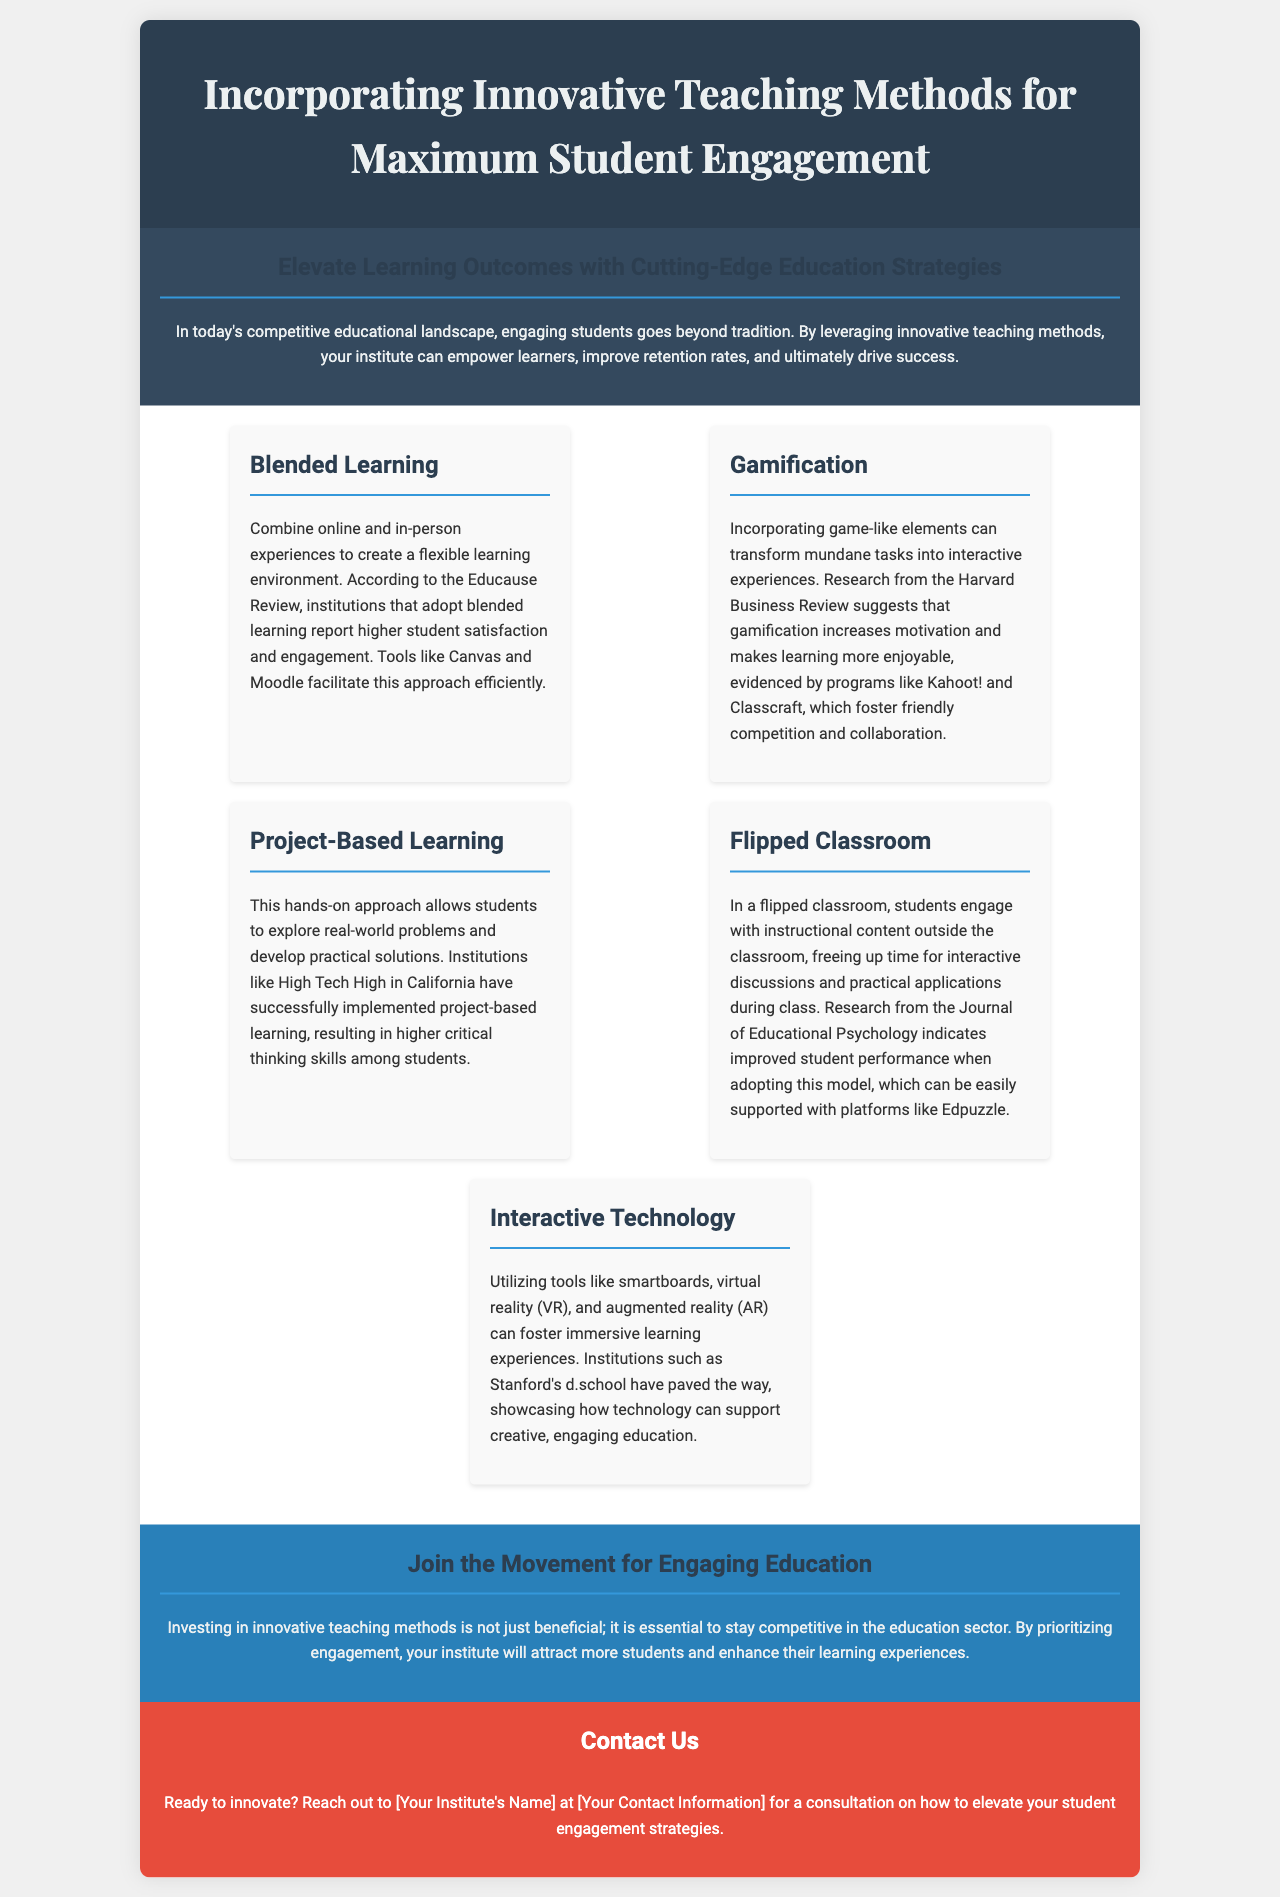What is the title of the brochure? The title is displayed prominently in the header of the document.
Answer: Incorporating Innovative Teaching Methods for Maximum Student Engagement What is one example of an innovative teaching method mentioned? This information can be found in the content sections of the brochure.
Answer: Blended Learning Which teaching method involves engaging with content outside of class? This refers to a specific instructional approach detailed in the document.
Answer: Flipped Classroom What is mentioned as a tool for facilitating blended learning? The document provides examples of tools that support this teaching method.
Answer: Canvas According to the brochure, what outcome do innovative teaching methods aim to improve? The brochure addresses the overall goals of adopting innovative strategies.
Answer: Retention rates What type of learning approach is described as hands-on and problem-solving? This can be identified in the descriptions of the various teaching methods.
Answer: Project-Based Learning Which institution is cited for successfully implementing project-based learning? The document specifies a particular institute as an example.
Answer: High Tech High What color is used for the conclusion section of the brochure? The design is highlighted through the color schemes used in the brochure layout.
Answer: Blue What is the call to action in the brochure? The document encourages readers to take a specific action.
Answer: Contact Us 